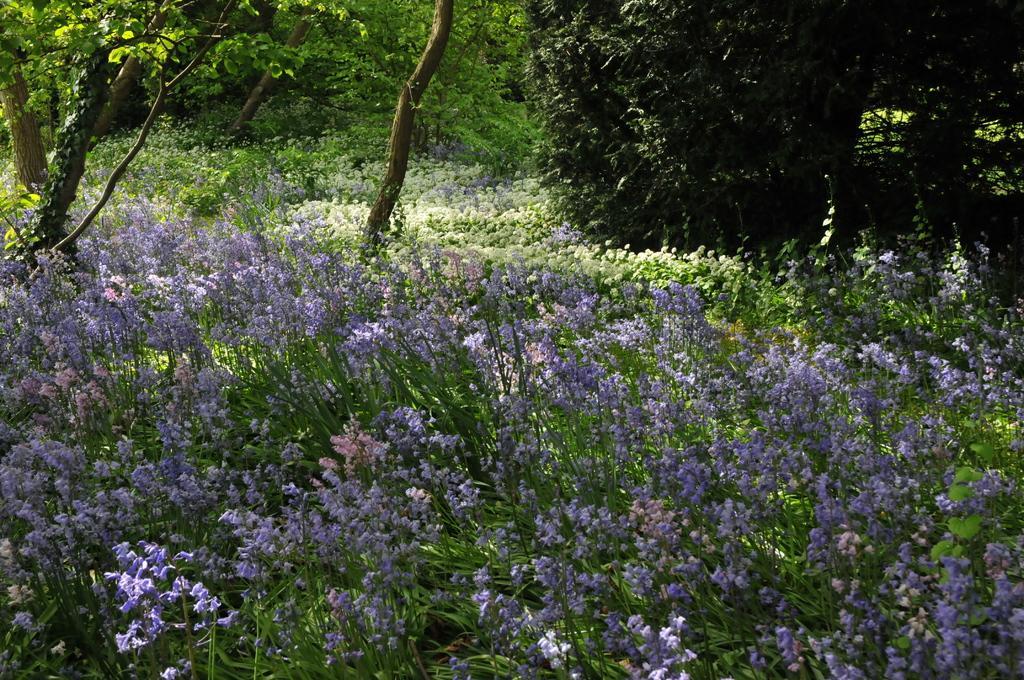Please provide a concise description of this image. In this image, we can see flowers and plants. Background we can see trees. 